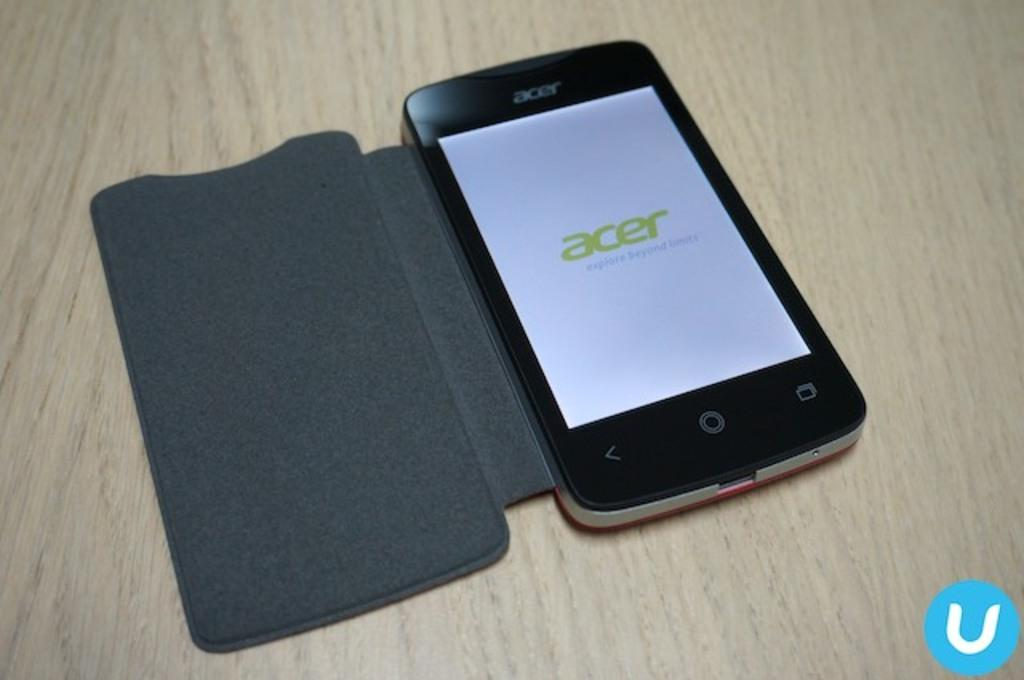<image>
Present a compact description of the photo's key features. A smartphone made by acer sits on a table. 